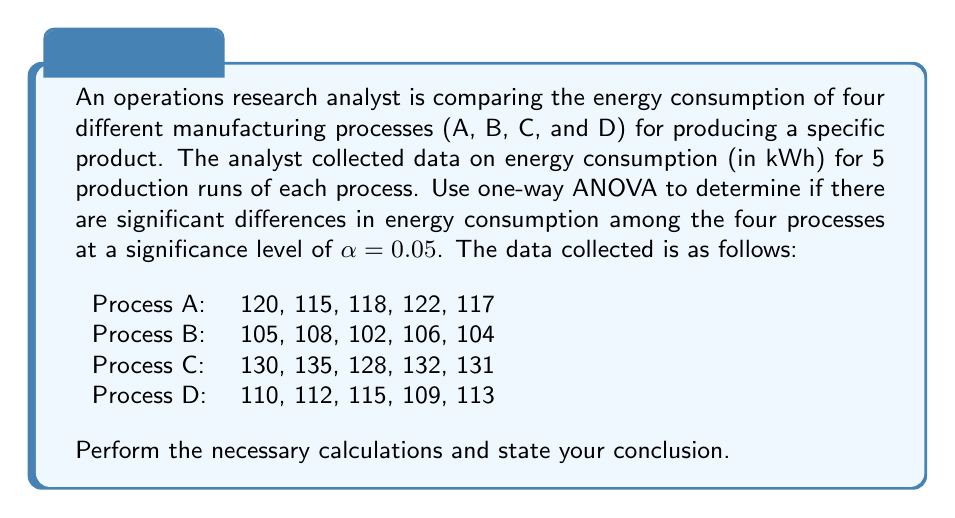Can you answer this question? To perform a one-way ANOVA, we need to follow these steps:

1. Calculate the sum of squares:
   a. Total Sum of Squares (SST)
   b. Between-group Sum of Squares (SSB)
   c. Within-group Sum of Squares (SSW)

2. Calculate the degrees of freedom:
   a. Total (dfT)
   b. Between-group (dfB)
   c. Within-group (dfW)

3. Calculate the mean squares:
   a. Between-group Mean Square (MSB)
   b. Within-group Mean Square (MSW)

4. Calculate the F-statistic

5. Compare the F-statistic with the critical F-value

Step 1: Calculate the sum of squares

a. Total Sum of Squares (SST):
$$SST = \sum_{i=1}^{n} (x_i - \bar{x})^2$$
where $x_i$ are all individual observations and $\bar{x}$ is the grand mean.

Grand mean: $\bar{x} = \frac{2323}{20} = 116.15$

SST = 2591.75

b. Between-group Sum of Squares (SSB):
$$SSB = \sum_{i=1}^{k} n_i(\bar{x_i} - \bar{x})^2$$
where $k$ is the number of groups, $n_i$ is the number of observations in each group, and $\bar{x_i}$ is the mean of each group.

Group means:
Process A: 118.4
Process B: 105.0
Process C: 131.2
Process D: 111.8

SSB = 2134.55

c. Within-group Sum of Squares (SSW):
$$SSW = SST - SSB$$
SSW = 2591.75 - 2134.55 = 457.2

Step 2: Calculate the degrees of freedom

a. Total: dfT = n - 1 = 20 - 1 = 19
b. Between-group: dfB = k - 1 = 4 - 1 = 3
c. Within-group: dfW = n - k = 20 - 4 = 16

Step 3: Calculate the mean squares

a. Between-group Mean Square: $MSB = \frac{SSB}{dfB} = \frac{2134.55}{3} = 711.52$
b. Within-group Mean Square: $MSW = \frac{SSW}{dfW} = \frac{457.2}{16} = 28.575$

Step 4: Calculate the F-statistic

$$F = \frac{MSB}{MSW} = \frac{711.52}{28.575} = 24.90$$

Step 5: Compare the F-statistic with the critical F-value

The critical F-value for $\alpha = 0.05$, dfB = 3, and dfW = 16 is approximately 3.24.

Since the calculated F-statistic (24.90) is greater than the critical F-value (3.24), we reject the null hypothesis.
Answer: The one-way ANOVA results show a statistically significant difference in energy consumption among the four manufacturing processes (F(3, 16) = 24.90, p < 0.05). This indicates that at least one of the processes has a significantly different energy consumption compared to the others. Further post-hoc tests (e.g., Tukey's HSD) would be needed to determine which specific processes differ from each other. 